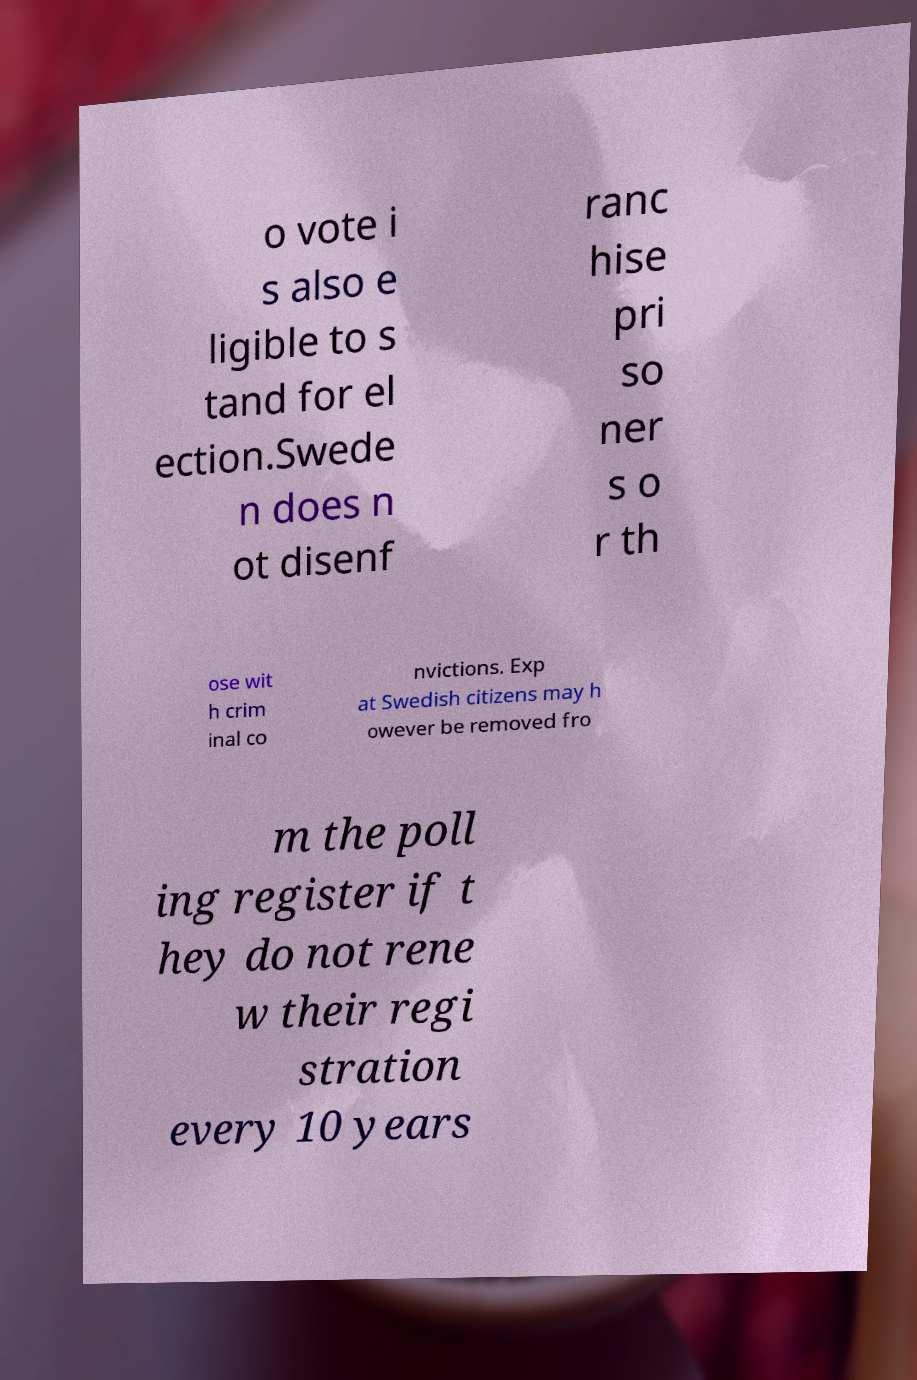Please read and relay the text visible in this image. What does it say? o vote i s also e ligible to s tand for el ection.Swede n does n ot disenf ranc hise pri so ner s o r th ose wit h crim inal co nvictions. Exp at Swedish citizens may h owever be removed fro m the poll ing register if t hey do not rene w their regi stration every 10 years 